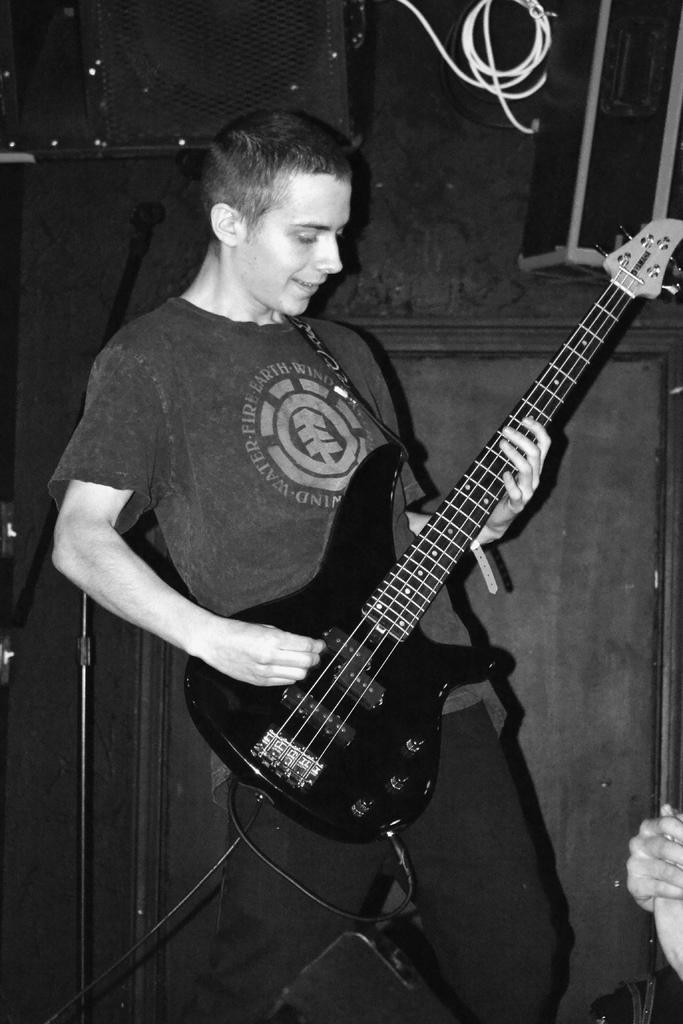Can you describe this image briefly? In this picture we can see a man who is playing guitar and this is the black and white picture. 